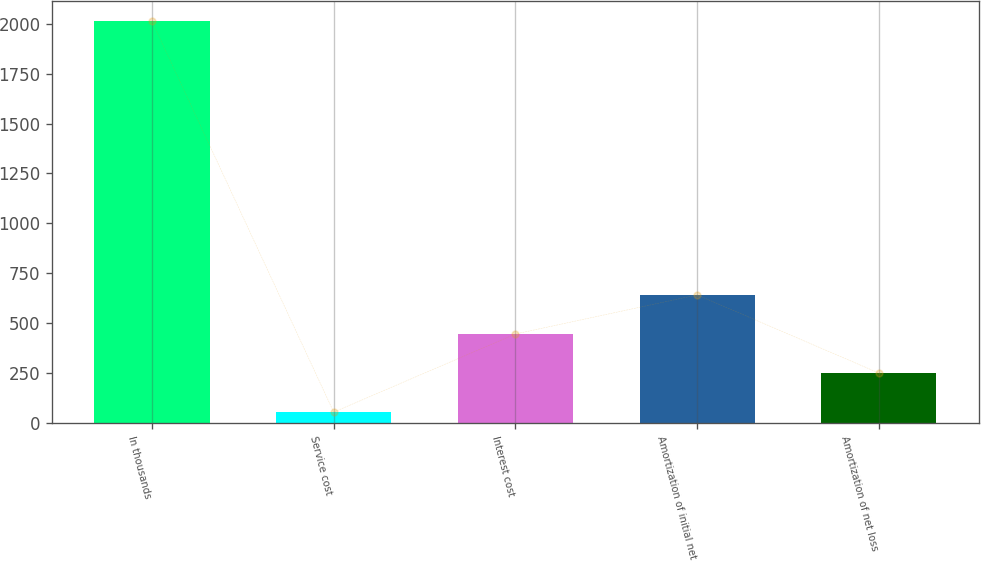<chart> <loc_0><loc_0><loc_500><loc_500><bar_chart><fcel>In thousands<fcel>Service cost<fcel>Interest cost<fcel>Amortization of initial net<fcel>Amortization of net loss<nl><fcel>2011<fcel>56<fcel>447<fcel>642.5<fcel>251.5<nl></chart> 